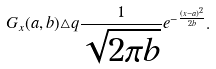Convert formula to latex. <formula><loc_0><loc_0><loc_500><loc_500>G _ { x } ( a , b ) \triangle q \frac { 1 } { \sqrt { 2 \pi b } } e ^ { - \frac { ( x - a ) ^ { 2 } } { 2 b } } .</formula> 